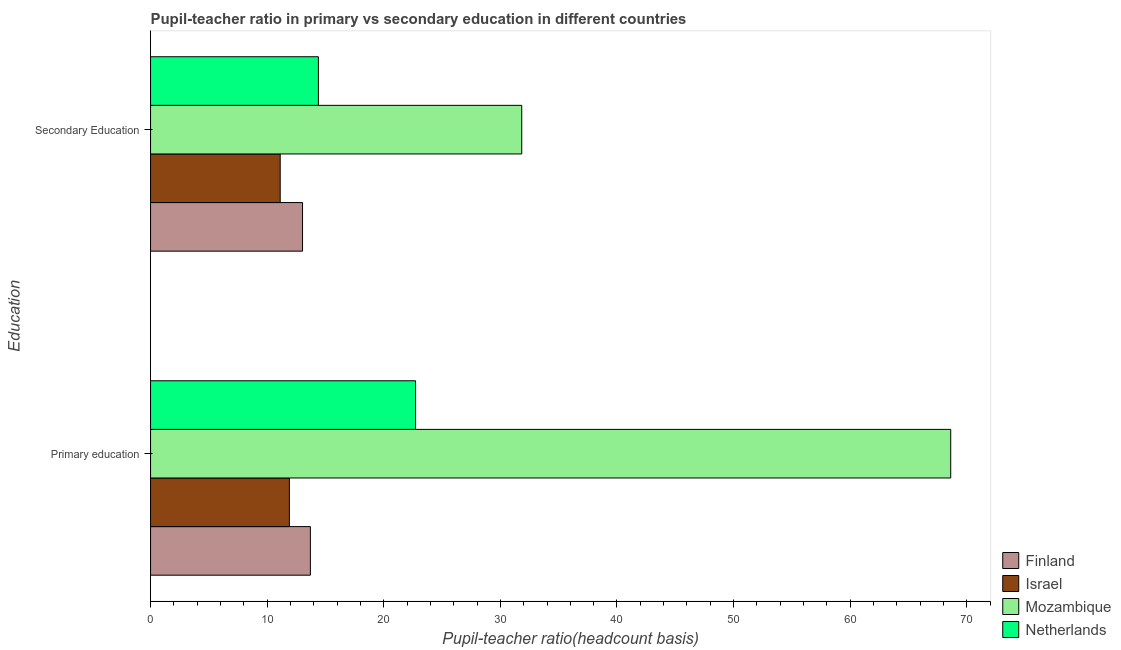Are the number of bars per tick equal to the number of legend labels?
Keep it short and to the point. Yes. How many bars are there on the 1st tick from the top?
Your answer should be compact. 4. How many bars are there on the 2nd tick from the bottom?
Offer a terse response. 4. What is the label of the 2nd group of bars from the top?
Provide a succinct answer. Primary education. What is the pupil-teacher ratio in primary education in Mozambique?
Make the answer very short. 68.62. Across all countries, what is the maximum pupil teacher ratio on secondary education?
Give a very brief answer. 31.83. Across all countries, what is the minimum pupil teacher ratio on secondary education?
Give a very brief answer. 11.12. In which country was the pupil teacher ratio on secondary education maximum?
Ensure brevity in your answer.  Mozambique. What is the total pupil-teacher ratio in primary education in the graph?
Provide a succinct answer. 116.96. What is the difference between the pupil teacher ratio on secondary education in Finland and that in Israel?
Provide a short and direct response. 1.91. What is the difference between the pupil-teacher ratio in primary education in Finland and the pupil teacher ratio on secondary education in Mozambique?
Offer a terse response. -18.13. What is the average pupil teacher ratio on secondary education per country?
Your response must be concise. 17.59. What is the difference between the pupil teacher ratio on secondary education and pupil-teacher ratio in primary education in Israel?
Ensure brevity in your answer.  -0.78. What is the ratio of the pupil-teacher ratio in primary education in Mozambique to that in Netherlands?
Your response must be concise. 3.02. In how many countries, is the pupil-teacher ratio in primary education greater than the average pupil-teacher ratio in primary education taken over all countries?
Offer a terse response. 1. What does the 3rd bar from the bottom in Secondary Education represents?
Offer a terse response. Mozambique. Are all the bars in the graph horizontal?
Ensure brevity in your answer.  Yes. What is the difference between two consecutive major ticks on the X-axis?
Your answer should be compact. 10. Does the graph contain any zero values?
Provide a short and direct response. No. Where does the legend appear in the graph?
Your answer should be very brief. Bottom right. How many legend labels are there?
Provide a short and direct response. 4. How are the legend labels stacked?
Your response must be concise. Vertical. What is the title of the graph?
Your answer should be very brief. Pupil-teacher ratio in primary vs secondary education in different countries. Does "Colombia" appear as one of the legend labels in the graph?
Ensure brevity in your answer.  No. What is the label or title of the X-axis?
Give a very brief answer. Pupil-teacher ratio(headcount basis). What is the label or title of the Y-axis?
Provide a short and direct response. Education. What is the Pupil-teacher ratio(headcount basis) in Finland in Primary education?
Offer a terse response. 13.7. What is the Pupil-teacher ratio(headcount basis) of Israel in Primary education?
Give a very brief answer. 11.9. What is the Pupil-teacher ratio(headcount basis) of Mozambique in Primary education?
Make the answer very short. 68.62. What is the Pupil-teacher ratio(headcount basis) in Netherlands in Primary education?
Provide a succinct answer. 22.73. What is the Pupil-teacher ratio(headcount basis) in Finland in Secondary Education?
Give a very brief answer. 13.03. What is the Pupil-teacher ratio(headcount basis) in Israel in Secondary Education?
Your answer should be compact. 11.12. What is the Pupil-teacher ratio(headcount basis) of Mozambique in Secondary Education?
Ensure brevity in your answer.  31.83. What is the Pupil-teacher ratio(headcount basis) of Netherlands in Secondary Education?
Ensure brevity in your answer.  14.39. Across all Education, what is the maximum Pupil-teacher ratio(headcount basis) of Finland?
Provide a succinct answer. 13.7. Across all Education, what is the maximum Pupil-teacher ratio(headcount basis) of Israel?
Your answer should be compact. 11.9. Across all Education, what is the maximum Pupil-teacher ratio(headcount basis) of Mozambique?
Offer a very short reply. 68.62. Across all Education, what is the maximum Pupil-teacher ratio(headcount basis) in Netherlands?
Your answer should be very brief. 22.73. Across all Education, what is the minimum Pupil-teacher ratio(headcount basis) in Finland?
Your response must be concise. 13.03. Across all Education, what is the minimum Pupil-teacher ratio(headcount basis) of Israel?
Provide a succinct answer. 11.12. Across all Education, what is the minimum Pupil-teacher ratio(headcount basis) in Mozambique?
Provide a short and direct response. 31.83. Across all Education, what is the minimum Pupil-teacher ratio(headcount basis) in Netherlands?
Your response must be concise. 14.39. What is the total Pupil-teacher ratio(headcount basis) in Finland in the graph?
Your answer should be compact. 26.74. What is the total Pupil-teacher ratio(headcount basis) of Israel in the graph?
Provide a succinct answer. 23.02. What is the total Pupil-teacher ratio(headcount basis) in Mozambique in the graph?
Keep it short and to the point. 100.45. What is the total Pupil-teacher ratio(headcount basis) of Netherlands in the graph?
Keep it short and to the point. 37.12. What is the difference between the Pupil-teacher ratio(headcount basis) of Finland in Primary education and that in Secondary Education?
Offer a very short reply. 0.67. What is the difference between the Pupil-teacher ratio(headcount basis) in Israel in Primary education and that in Secondary Education?
Your response must be concise. 0.78. What is the difference between the Pupil-teacher ratio(headcount basis) of Mozambique in Primary education and that in Secondary Education?
Your response must be concise. 36.79. What is the difference between the Pupil-teacher ratio(headcount basis) in Netherlands in Primary education and that in Secondary Education?
Offer a very short reply. 8.33. What is the difference between the Pupil-teacher ratio(headcount basis) in Finland in Primary education and the Pupil-teacher ratio(headcount basis) in Israel in Secondary Education?
Your answer should be compact. 2.59. What is the difference between the Pupil-teacher ratio(headcount basis) in Finland in Primary education and the Pupil-teacher ratio(headcount basis) in Mozambique in Secondary Education?
Offer a very short reply. -18.13. What is the difference between the Pupil-teacher ratio(headcount basis) of Finland in Primary education and the Pupil-teacher ratio(headcount basis) of Netherlands in Secondary Education?
Make the answer very short. -0.69. What is the difference between the Pupil-teacher ratio(headcount basis) in Israel in Primary education and the Pupil-teacher ratio(headcount basis) in Mozambique in Secondary Education?
Your answer should be very brief. -19.93. What is the difference between the Pupil-teacher ratio(headcount basis) of Israel in Primary education and the Pupil-teacher ratio(headcount basis) of Netherlands in Secondary Education?
Your response must be concise. -2.49. What is the difference between the Pupil-teacher ratio(headcount basis) of Mozambique in Primary education and the Pupil-teacher ratio(headcount basis) of Netherlands in Secondary Education?
Give a very brief answer. 54.23. What is the average Pupil-teacher ratio(headcount basis) in Finland per Education?
Your answer should be very brief. 13.37. What is the average Pupil-teacher ratio(headcount basis) of Israel per Education?
Offer a terse response. 11.51. What is the average Pupil-teacher ratio(headcount basis) in Mozambique per Education?
Provide a short and direct response. 50.23. What is the average Pupil-teacher ratio(headcount basis) of Netherlands per Education?
Offer a very short reply. 18.56. What is the difference between the Pupil-teacher ratio(headcount basis) in Finland and Pupil-teacher ratio(headcount basis) in Israel in Primary education?
Offer a very short reply. 1.8. What is the difference between the Pupil-teacher ratio(headcount basis) of Finland and Pupil-teacher ratio(headcount basis) of Mozambique in Primary education?
Your answer should be very brief. -54.92. What is the difference between the Pupil-teacher ratio(headcount basis) in Finland and Pupil-teacher ratio(headcount basis) in Netherlands in Primary education?
Keep it short and to the point. -9.02. What is the difference between the Pupil-teacher ratio(headcount basis) in Israel and Pupil-teacher ratio(headcount basis) in Mozambique in Primary education?
Make the answer very short. -56.72. What is the difference between the Pupil-teacher ratio(headcount basis) of Israel and Pupil-teacher ratio(headcount basis) of Netherlands in Primary education?
Provide a short and direct response. -10.82. What is the difference between the Pupil-teacher ratio(headcount basis) of Mozambique and Pupil-teacher ratio(headcount basis) of Netherlands in Primary education?
Keep it short and to the point. 45.89. What is the difference between the Pupil-teacher ratio(headcount basis) of Finland and Pupil-teacher ratio(headcount basis) of Israel in Secondary Education?
Provide a succinct answer. 1.91. What is the difference between the Pupil-teacher ratio(headcount basis) of Finland and Pupil-teacher ratio(headcount basis) of Mozambique in Secondary Education?
Provide a succinct answer. -18.8. What is the difference between the Pupil-teacher ratio(headcount basis) in Finland and Pupil-teacher ratio(headcount basis) in Netherlands in Secondary Education?
Offer a terse response. -1.36. What is the difference between the Pupil-teacher ratio(headcount basis) of Israel and Pupil-teacher ratio(headcount basis) of Mozambique in Secondary Education?
Your response must be concise. -20.71. What is the difference between the Pupil-teacher ratio(headcount basis) in Israel and Pupil-teacher ratio(headcount basis) in Netherlands in Secondary Education?
Provide a succinct answer. -3.28. What is the difference between the Pupil-teacher ratio(headcount basis) in Mozambique and Pupil-teacher ratio(headcount basis) in Netherlands in Secondary Education?
Provide a short and direct response. 17.44. What is the ratio of the Pupil-teacher ratio(headcount basis) of Finland in Primary education to that in Secondary Education?
Provide a short and direct response. 1.05. What is the ratio of the Pupil-teacher ratio(headcount basis) in Israel in Primary education to that in Secondary Education?
Make the answer very short. 1.07. What is the ratio of the Pupil-teacher ratio(headcount basis) of Mozambique in Primary education to that in Secondary Education?
Your answer should be very brief. 2.16. What is the ratio of the Pupil-teacher ratio(headcount basis) of Netherlands in Primary education to that in Secondary Education?
Your answer should be very brief. 1.58. What is the difference between the highest and the second highest Pupil-teacher ratio(headcount basis) in Finland?
Offer a terse response. 0.67. What is the difference between the highest and the second highest Pupil-teacher ratio(headcount basis) of Israel?
Your response must be concise. 0.78. What is the difference between the highest and the second highest Pupil-teacher ratio(headcount basis) of Mozambique?
Make the answer very short. 36.79. What is the difference between the highest and the second highest Pupil-teacher ratio(headcount basis) of Netherlands?
Provide a succinct answer. 8.33. What is the difference between the highest and the lowest Pupil-teacher ratio(headcount basis) in Finland?
Keep it short and to the point. 0.67. What is the difference between the highest and the lowest Pupil-teacher ratio(headcount basis) of Israel?
Give a very brief answer. 0.78. What is the difference between the highest and the lowest Pupil-teacher ratio(headcount basis) of Mozambique?
Ensure brevity in your answer.  36.79. What is the difference between the highest and the lowest Pupil-teacher ratio(headcount basis) of Netherlands?
Ensure brevity in your answer.  8.33. 